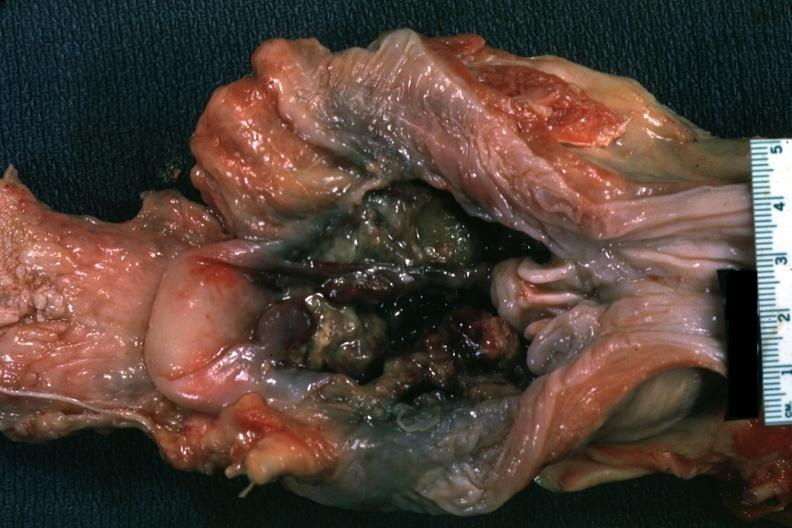where is this?
Answer the question using a single word or phrase. Oral 